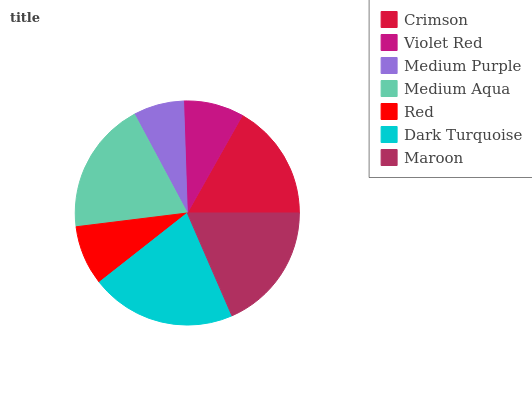Is Medium Purple the minimum?
Answer yes or no. Yes. Is Dark Turquoise the maximum?
Answer yes or no. Yes. Is Violet Red the minimum?
Answer yes or no. No. Is Violet Red the maximum?
Answer yes or no. No. Is Crimson greater than Violet Red?
Answer yes or no. Yes. Is Violet Red less than Crimson?
Answer yes or no. Yes. Is Violet Red greater than Crimson?
Answer yes or no. No. Is Crimson less than Violet Red?
Answer yes or no. No. Is Crimson the high median?
Answer yes or no. Yes. Is Crimson the low median?
Answer yes or no. Yes. Is Violet Red the high median?
Answer yes or no. No. Is Medium Aqua the low median?
Answer yes or no. No. 